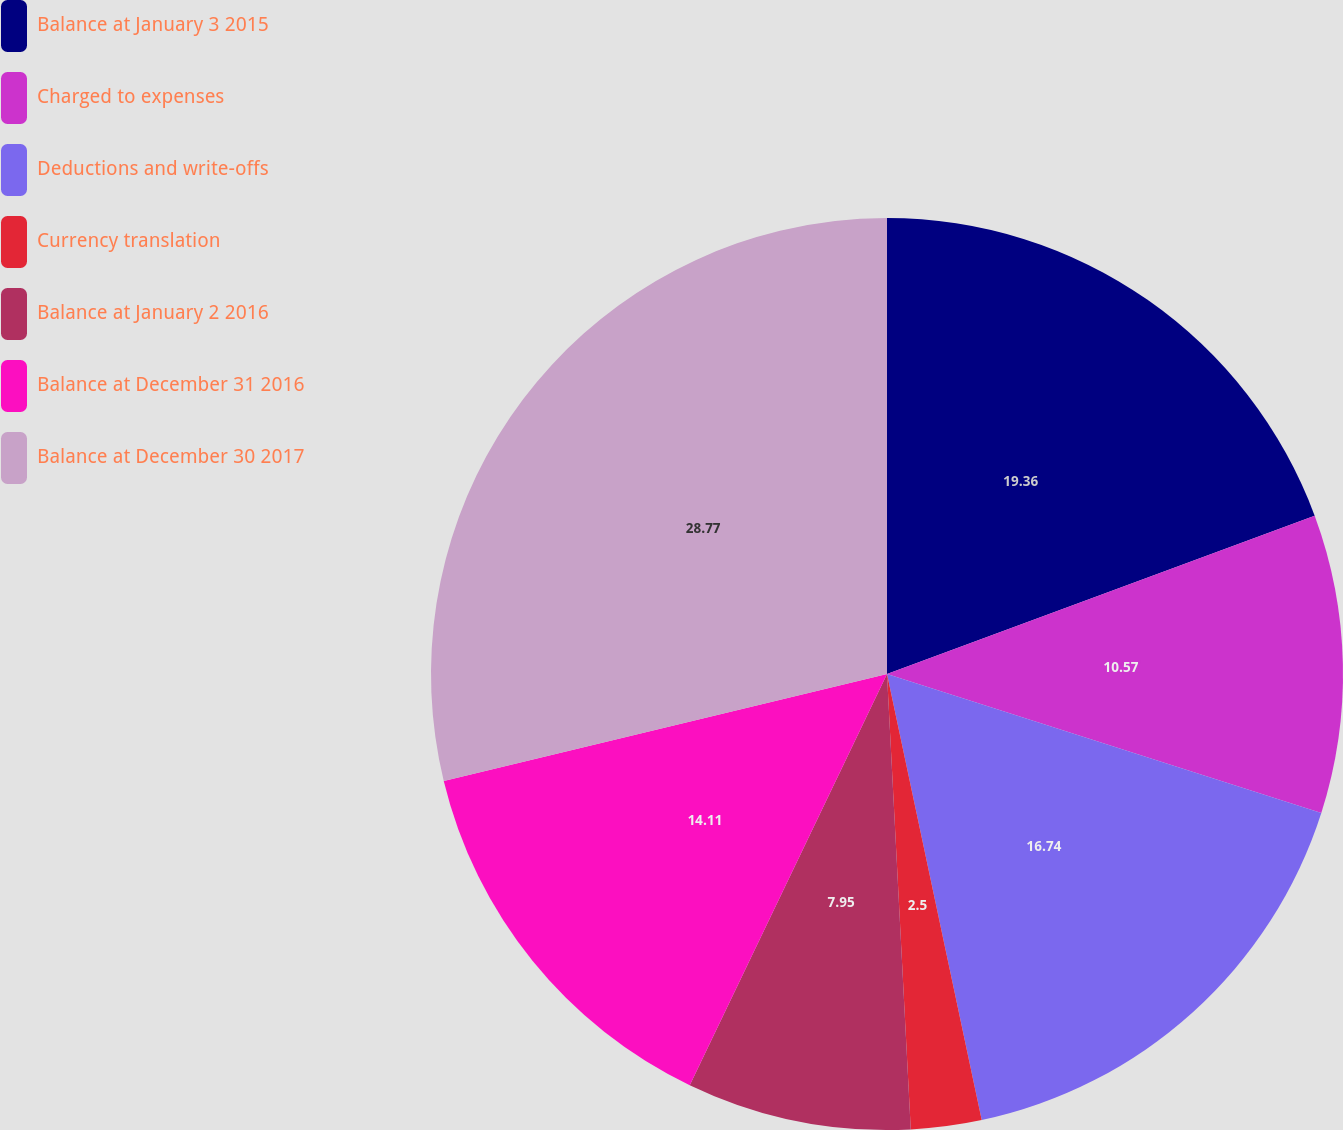Convert chart to OTSL. <chart><loc_0><loc_0><loc_500><loc_500><pie_chart><fcel>Balance at January 3 2015<fcel>Charged to expenses<fcel>Deductions and write-offs<fcel>Currency translation<fcel>Balance at January 2 2016<fcel>Balance at December 31 2016<fcel>Balance at December 30 2017<nl><fcel>19.36%<fcel>10.57%<fcel>16.74%<fcel>2.5%<fcel>7.95%<fcel>14.11%<fcel>28.77%<nl></chart> 